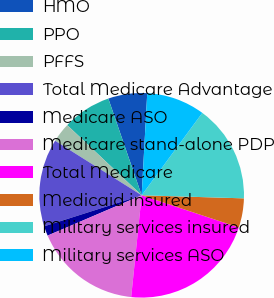<chart> <loc_0><loc_0><loc_500><loc_500><pie_chart><fcel>HMO<fcel>PPO<fcel>PFFS<fcel>Total Medicare Advantage<fcel>Medicare ASO<fcel>Medicare stand-alone PDP<fcel>Total Medicare<fcel>Medicaid insured<fcel>Military services insured<fcel>Military services ASO<nl><fcel>6.15%<fcel>7.69%<fcel>3.08%<fcel>13.85%<fcel>1.54%<fcel>16.92%<fcel>21.54%<fcel>4.62%<fcel>15.38%<fcel>9.23%<nl></chart> 